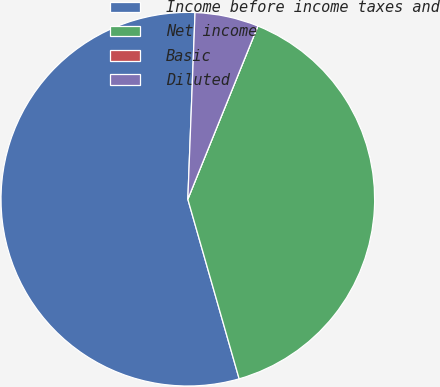Convert chart to OTSL. <chart><loc_0><loc_0><loc_500><loc_500><pie_chart><fcel>Income before income taxes and<fcel>Net income<fcel>Basic<fcel>Diluted<nl><fcel>55.04%<fcel>39.45%<fcel>0.0%<fcel>5.5%<nl></chart> 